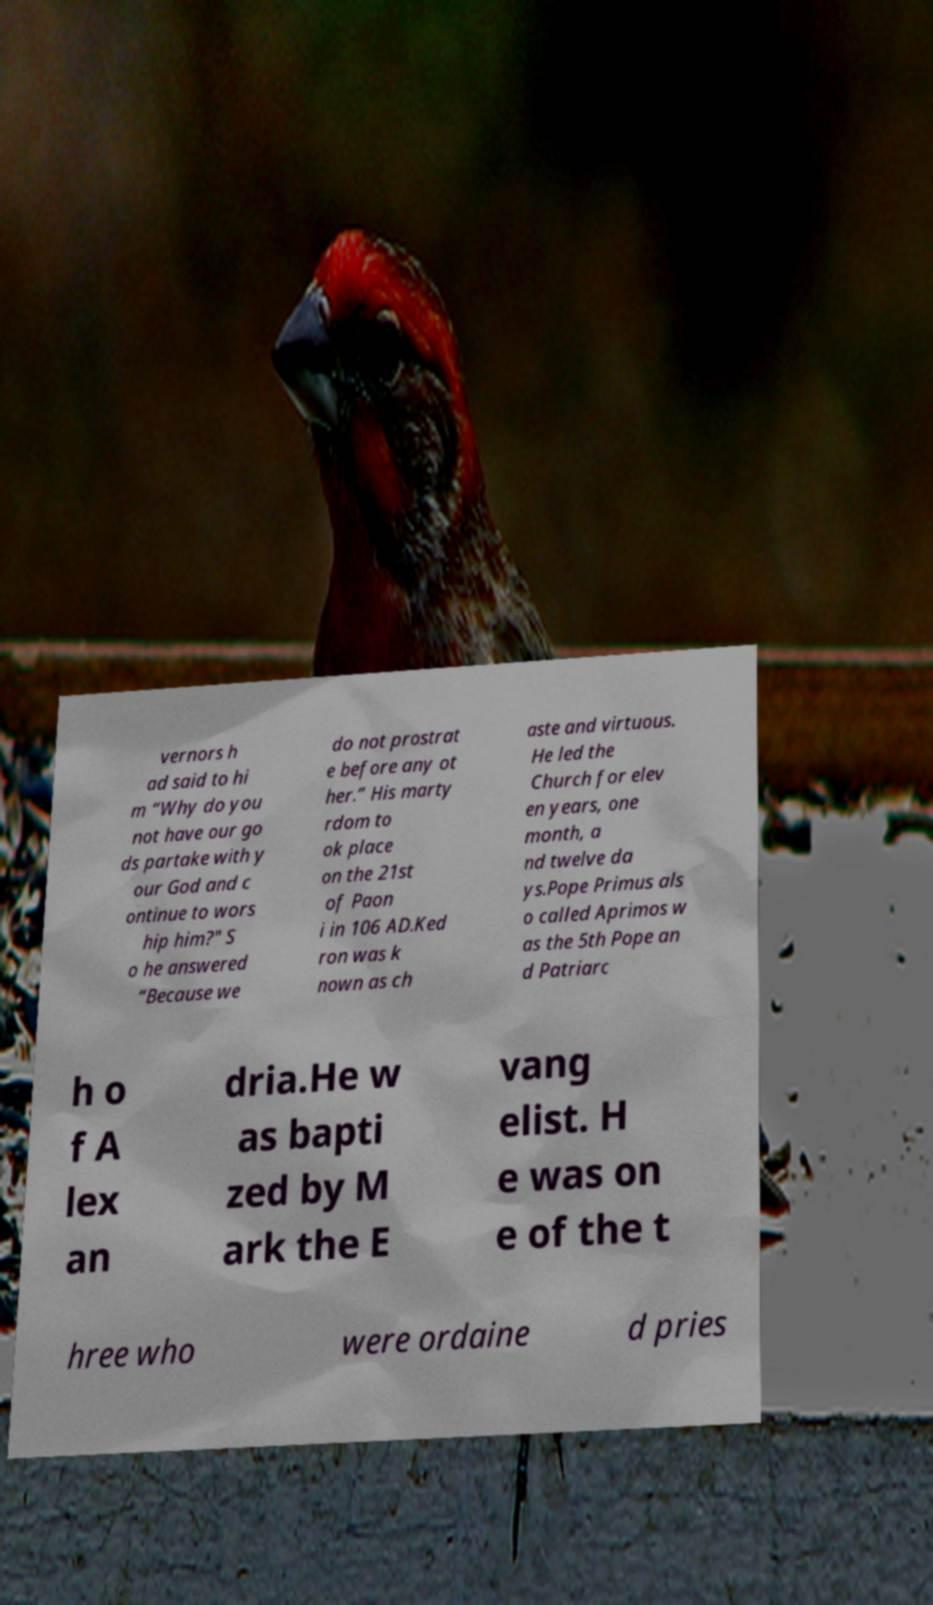For documentation purposes, I need the text within this image transcribed. Could you provide that? vernors h ad said to hi m “Why do you not have our go ds partake with y our God and c ontinue to wors hip him?" S o he answered “Because we do not prostrat e before any ot her.” His marty rdom to ok place on the 21st of Paon i in 106 AD.Ked ron was k nown as ch aste and virtuous. He led the Church for elev en years, one month, a nd twelve da ys.Pope Primus als o called Aprimos w as the 5th Pope an d Patriarc h o f A lex an dria.He w as bapti zed by M ark the E vang elist. H e was on e of the t hree who were ordaine d pries 